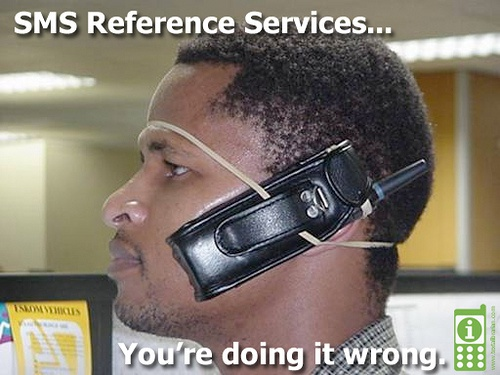Describe the objects in this image and their specific colors. I can see people in gray, black, and darkgray tones and cell phone in gray, black, and darkgray tones in this image. 